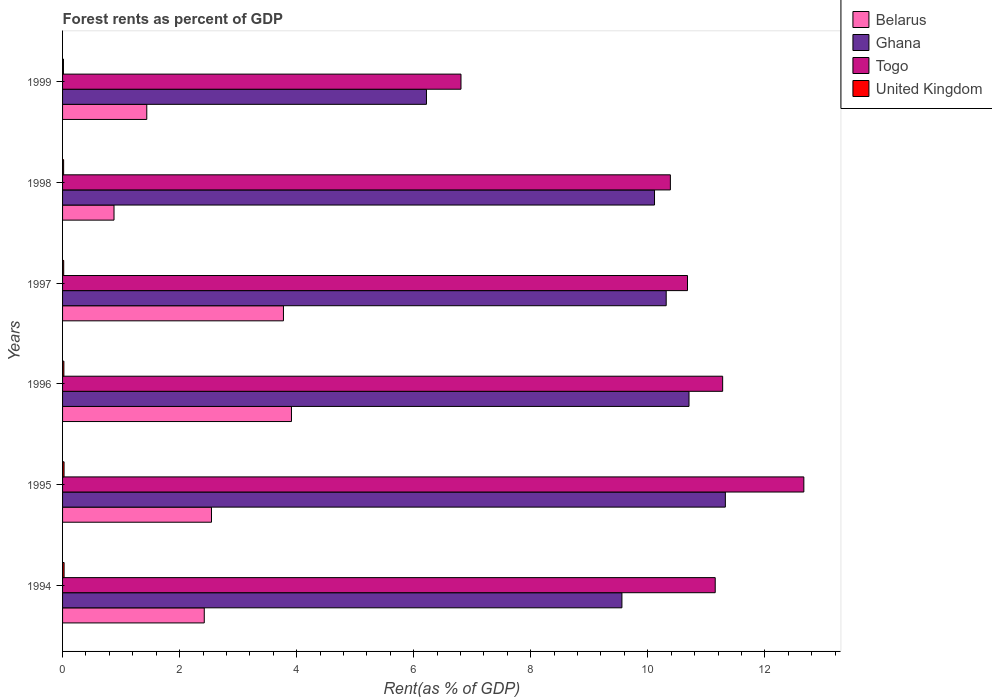How many groups of bars are there?
Offer a very short reply. 6. Are the number of bars per tick equal to the number of legend labels?
Provide a succinct answer. Yes. How many bars are there on the 6th tick from the top?
Your answer should be compact. 4. What is the forest rent in Togo in 1996?
Keep it short and to the point. 11.28. Across all years, what is the maximum forest rent in Belarus?
Provide a succinct answer. 3.91. Across all years, what is the minimum forest rent in Belarus?
Your response must be concise. 0.88. In which year was the forest rent in Togo minimum?
Your answer should be very brief. 1999. What is the total forest rent in United Kingdom in the graph?
Keep it short and to the point. 0.13. What is the difference between the forest rent in United Kingdom in 1994 and that in 1998?
Give a very brief answer. 0.01. What is the difference between the forest rent in Ghana in 1997 and the forest rent in United Kingdom in 1995?
Your answer should be compact. 10.29. What is the average forest rent in Togo per year?
Offer a terse response. 10.5. In the year 1999, what is the difference between the forest rent in Belarus and forest rent in Togo?
Ensure brevity in your answer.  -5.37. In how many years, is the forest rent in Belarus greater than 10 %?
Your response must be concise. 0. What is the ratio of the forest rent in Belarus in 1997 to that in 1999?
Your answer should be very brief. 2.62. Is the difference between the forest rent in Belarus in 1995 and 1999 greater than the difference between the forest rent in Togo in 1995 and 1999?
Your answer should be very brief. No. What is the difference between the highest and the second highest forest rent in Belarus?
Provide a succinct answer. 0.14. What is the difference between the highest and the lowest forest rent in Belarus?
Offer a terse response. 3.03. What does the 2nd bar from the top in 1999 represents?
Provide a succinct answer. Togo. What does the 3rd bar from the bottom in 1999 represents?
Offer a terse response. Togo. Is it the case that in every year, the sum of the forest rent in United Kingdom and forest rent in Togo is greater than the forest rent in Ghana?
Make the answer very short. Yes. Are all the bars in the graph horizontal?
Provide a succinct answer. Yes. How many years are there in the graph?
Your response must be concise. 6. Are the values on the major ticks of X-axis written in scientific E-notation?
Keep it short and to the point. No. Does the graph contain any zero values?
Your response must be concise. No. Where does the legend appear in the graph?
Make the answer very short. Top right. How many legend labels are there?
Your answer should be compact. 4. What is the title of the graph?
Your answer should be very brief. Forest rents as percent of GDP. Does "Uganda" appear as one of the legend labels in the graph?
Keep it short and to the point. No. What is the label or title of the X-axis?
Make the answer very short. Rent(as % of GDP). What is the Rent(as % of GDP) of Belarus in 1994?
Offer a terse response. 2.42. What is the Rent(as % of GDP) in Ghana in 1994?
Keep it short and to the point. 9.56. What is the Rent(as % of GDP) in Togo in 1994?
Your answer should be compact. 11.15. What is the Rent(as % of GDP) of United Kingdom in 1994?
Offer a very short reply. 0.03. What is the Rent(as % of GDP) of Belarus in 1995?
Provide a succinct answer. 2.54. What is the Rent(as % of GDP) in Ghana in 1995?
Make the answer very short. 11.33. What is the Rent(as % of GDP) of Togo in 1995?
Ensure brevity in your answer.  12.67. What is the Rent(as % of GDP) of United Kingdom in 1995?
Your answer should be compact. 0.03. What is the Rent(as % of GDP) of Belarus in 1996?
Offer a terse response. 3.91. What is the Rent(as % of GDP) of Ghana in 1996?
Your answer should be compact. 10.7. What is the Rent(as % of GDP) of Togo in 1996?
Ensure brevity in your answer.  11.28. What is the Rent(as % of GDP) of United Kingdom in 1996?
Your response must be concise. 0.02. What is the Rent(as % of GDP) of Belarus in 1997?
Keep it short and to the point. 3.77. What is the Rent(as % of GDP) of Ghana in 1997?
Your answer should be very brief. 10.31. What is the Rent(as % of GDP) of Togo in 1997?
Offer a very short reply. 10.68. What is the Rent(as % of GDP) of United Kingdom in 1997?
Offer a terse response. 0.02. What is the Rent(as % of GDP) in Belarus in 1998?
Offer a terse response. 0.88. What is the Rent(as % of GDP) in Ghana in 1998?
Provide a short and direct response. 10.12. What is the Rent(as % of GDP) in Togo in 1998?
Offer a very short reply. 10.39. What is the Rent(as % of GDP) in United Kingdom in 1998?
Your response must be concise. 0.02. What is the Rent(as % of GDP) in Belarus in 1999?
Your answer should be compact. 1.44. What is the Rent(as % of GDP) in Ghana in 1999?
Your answer should be very brief. 6.22. What is the Rent(as % of GDP) of Togo in 1999?
Offer a very short reply. 6.81. What is the Rent(as % of GDP) in United Kingdom in 1999?
Your response must be concise. 0.02. Across all years, what is the maximum Rent(as % of GDP) in Belarus?
Provide a succinct answer. 3.91. Across all years, what is the maximum Rent(as % of GDP) of Ghana?
Give a very brief answer. 11.33. Across all years, what is the maximum Rent(as % of GDP) of Togo?
Offer a very short reply. 12.67. Across all years, what is the maximum Rent(as % of GDP) in United Kingdom?
Your answer should be compact. 0.03. Across all years, what is the minimum Rent(as % of GDP) of Belarus?
Offer a terse response. 0.88. Across all years, what is the minimum Rent(as % of GDP) in Ghana?
Give a very brief answer. 6.22. Across all years, what is the minimum Rent(as % of GDP) of Togo?
Your response must be concise. 6.81. Across all years, what is the minimum Rent(as % of GDP) of United Kingdom?
Keep it short and to the point. 0.02. What is the total Rent(as % of GDP) in Belarus in the graph?
Your answer should be compact. 14.97. What is the total Rent(as % of GDP) in Ghana in the graph?
Provide a succinct answer. 58.24. What is the total Rent(as % of GDP) in Togo in the graph?
Ensure brevity in your answer.  62.97. What is the total Rent(as % of GDP) in United Kingdom in the graph?
Keep it short and to the point. 0.13. What is the difference between the Rent(as % of GDP) of Belarus in 1994 and that in 1995?
Offer a very short reply. -0.12. What is the difference between the Rent(as % of GDP) in Ghana in 1994 and that in 1995?
Make the answer very short. -1.77. What is the difference between the Rent(as % of GDP) in Togo in 1994 and that in 1995?
Offer a very short reply. -1.51. What is the difference between the Rent(as % of GDP) in United Kingdom in 1994 and that in 1995?
Your response must be concise. 0. What is the difference between the Rent(as % of GDP) of Belarus in 1994 and that in 1996?
Provide a succinct answer. -1.49. What is the difference between the Rent(as % of GDP) in Ghana in 1994 and that in 1996?
Keep it short and to the point. -1.15. What is the difference between the Rent(as % of GDP) in Togo in 1994 and that in 1996?
Give a very brief answer. -0.13. What is the difference between the Rent(as % of GDP) in United Kingdom in 1994 and that in 1996?
Your response must be concise. 0. What is the difference between the Rent(as % of GDP) of Belarus in 1994 and that in 1997?
Give a very brief answer. -1.35. What is the difference between the Rent(as % of GDP) in Ghana in 1994 and that in 1997?
Your response must be concise. -0.76. What is the difference between the Rent(as % of GDP) of Togo in 1994 and that in 1997?
Offer a terse response. 0.47. What is the difference between the Rent(as % of GDP) in United Kingdom in 1994 and that in 1997?
Your answer should be very brief. 0.01. What is the difference between the Rent(as % of GDP) of Belarus in 1994 and that in 1998?
Provide a succinct answer. 1.54. What is the difference between the Rent(as % of GDP) in Ghana in 1994 and that in 1998?
Make the answer very short. -0.56. What is the difference between the Rent(as % of GDP) of Togo in 1994 and that in 1998?
Keep it short and to the point. 0.77. What is the difference between the Rent(as % of GDP) of United Kingdom in 1994 and that in 1998?
Your answer should be very brief. 0.01. What is the difference between the Rent(as % of GDP) in Belarus in 1994 and that in 1999?
Make the answer very short. 0.98. What is the difference between the Rent(as % of GDP) of Ghana in 1994 and that in 1999?
Your answer should be compact. 3.34. What is the difference between the Rent(as % of GDP) of Togo in 1994 and that in 1999?
Make the answer very short. 4.34. What is the difference between the Rent(as % of GDP) in United Kingdom in 1994 and that in 1999?
Your answer should be compact. 0.01. What is the difference between the Rent(as % of GDP) of Belarus in 1995 and that in 1996?
Provide a short and direct response. -1.37. What is the difference between the Rent(as % of GDP) in Ghana in 1995 and that in 1996?
Your answer should be compact. 0.62. What is the difference between the Rent(as % of GDP) in Togo in 1995 and that in 1996?
Offer a terse response. 1.39. What is the difference between the Rent(as % of GDP) in United Kingdom in 1995 and that in 1996?
Ensure brevity in your answer.  0. What is the difference between the Rent(as % of GDP) of Belarus in 1995 and that in 1997?
Your answer should be compact. -1.23. What is the difference between the Rent(as % of GDP) in Ghana in 1995 and that in 1997?
Keep it short and to the point. 1.01. What is the difference between the Rent(as % of GDP) of Togo in 1995 and that in 1997?
Provide a succinct answer. 1.99. What is the difference between the Rent(as % of GDP) of United Kingdom in 1995 and that in 1997?
Your answer should be compact. 0.01. What is the difference between the Rent(as % of GDP) of Belarus in 1995 and that in 1998?
Your answer should be very brief. 1.67. What is the difference between the Rent(as % of GDP) in Ghana in 1995 and that in 1998?
Make the answer very short. 1.21. What is the difference between the Rent(as % of GDP) in Togo in 1995 and that in 1998?
Provide a short and direct response. 2.28. What is the difference between the Rent(as % of GDP) of United Kingdom in 1995 and that in 1998?
Your answer should be compact. 0.01. What is the difference between the Rent(as % of GDP) in Belarus in 1995 and that in 1999?
Your response must be concise. 1.11. What is the difference between the Rent(as % of GDP) of Ghana in 1995 and that in 1999?
Give a very brief answer. 5.11. What is the difference between the Rent(as % of GDP) in Togo in 1995 and that in 1999?
Your answer should be very brief. 5.86. What is the difference between the Rent(as % of GDP) of United Kingdom in 1995 and that in 1999?
Give a very brief answer. 0.01. What is the difference between the Rent(as % of GDP) of Belarus in 1996 and that in 1997?
Your response must be concise. 0.14. What is the difference between the Rent(as % of GDP) of Ghana in 1996 and that in 1997?
Provide a succinct answer. 0.39. What is the difference between the Rent(as % of GDP) in Togo in 1996 and that in 1997?
Your response must be concise. 0.6. What is the difference between the Rent(as % of GDP) in United Kingdom in 1996 and that in 1997?
Keep it short and to the point. 0. What is the difference between the Rent(as % of GDP) of Belarus in 1996 and that in 1998?
Your answer should be very brief. 3.03. What is the difference between the Rent(as % of GDP) in Ghana in 1996 and that in 1998?
Provide a succinct answer. 0.59. What is the difference between the Rent(as % of GDP) in Togo in 1996 and that in 1998?
Offer a terse response. 0.89. What is the difference between the Rent(as % of GDP) of United Kingdom in 1996 and that in 1998?
Provide a short and direct response. 0. What is the difference between the Rent(as % of GDP) of Belarus in 1996 and that in 1999?
Give a very brief answer. 2.47. What is the difference between the Rent(as % of GDP) in Ghana in 1996 and that in 1999?
Provide a succinct answer. 4.49. What is the difference between the Rent(as % of GDP) of Togo in 1996 and that in 1999?
Provide a short and direct response. 4.47. What is the difference between the Rent(as % of GDP) of United Kingdom in 1996 and that in 1999?
Keep it short and to the point. 0.01. What is the difference between the Rent(as % of GDP) of Belarus in 1997 and that in 1998?
Provide a succinct answer. 2.9. What is the difference between the Rent(as % of GDP) of Ghana in 1997 and that in 1998?
Your answer should be compact. 0.2. What is the difference between the Rent(as % of GDP) of Togo in 1997 and that in 1998?
Keep it short and to the point. 0.29. What is the difference between the Rent(as % of GDP) of United Kingdom in 1997 and that in 1998?
Offer a very short reply. 0. What is the difference between the Rent(as % of GDP) of Belarus in 1997 and that in 1999?
Ensure brevity in your answer.  2.34. What is the difference between the Rent(as % of GDP) in Ghana in 1997 and that in 1999?
Keep it short and to the point. 4.1. What is the difference between the Rent(as % of GDP) of Togo in 1997 and that in 1999?
Provide a succinct answer. 3.87. What is the difference between the Rent(as % of GDP) of United Kingdom in 1997 and that in 1999?
Provide a short and direct response. 0. What is the difference between the Rent(as % of GDP) of Belarus in 1998 and that in 1999?
Your response must be concise. -0.56. What is the difference between the Rent(as % of GDP) of Ghana in 1998 and that in 1999?
Your answer should be compact. 3.9. What is the difference between the Rent(as % of GDP) in Togo in 1998 and that in 1999?
Offer a very short reply. 3.58. What is the difference between the Rent(as % of GDP) in United Kingdom in 1998 and that in 1999?
Give a very brief answer. 0. What is the difference between the Rent(as % of GDP) in Belarus in 1994 and the Rent(as % of GDP) in Ghana in 1995?
Your response must be concise. -8.9. What is the difference between the Rent(as % of GDP) in Belarus in 1994 and the Rent(as % of GDP) in Togo in 1995?
Ensure brevity in your answer.  -10.25. What is the difference between the Rent(as % of GDP) of Belarus in 1994 and the Rent(as % of GDP) of United Kingdom in 1995?
Your answer should be compact. 2.4. What is the difference between the Rent(as % of GDP) in Ghana in 1994 and the Rent(as % of GDP) in Togo in 1995?
Give a very brief answer. -3.11. What is the difference between the Rent(as % of GDP) in Ghana in 1994 and the Rent(as % of GDP) in United Kingdom in 1995?
Provide a short and direct response. 9.53. What is the difference between the Rent(as % of GDP) of Togo in 1994 and the Rent(as % of GDP) of United Kingdom in 1995?
Your response must be concise. 11.13. What is the difference between the Rent(as % of GDP) in Belarus in 1994 and the Rent(as % of GDP) in Ghana in 1996?
Provide a succinct answer. -8.28. What is the difference between the Rent(as % of GDP) of Belarus in 1994 and the Rent(as % of GDP) of Togo in 1996?
Provide a short and direct response. -8.86. What is the difference between the Rent(as % of GDP) of Belarus in 1994 and the Rent(as % of GDP) of United Kingdom in 1996?
Make the answer very short. 2.4. What is the difference between the Rent(as % of GDP) of Ghana in 1994 and the Rent(as % of GDP) of Togo in 1996?
Your answer should be compact. -1.72. What is the difference between the Rent(as % of GDP) of Ghana in 1994 and the Rent(as % of GDP) of United Kingdom in 1996?
Make the answer very short. 9.54. What is the difference between the Rent(as % of GDP) of Togo in 1994 and the Rent(as % of GDP) of United Kingdom in 1996?
Your answer should be compact. 11.13. What is the difference between the Rent(as % of GDP) in Belarus in 1994 and the Rent(as % of GDP) in Ghana in 1997?
Ensure brevity in your answer.  -7.89. What is the difference between the Rent(as % of GDP) of Belarus in 1994 and the Rent(as % of GDP) of Togo in 1997?
Offer a terse response. -8.26. What is the difference between the Rent(as % of GDP) of Belarus in 1994 and the Rent(as % of GDP) of United Kingdom in 1997?
Your answer should be compact. 2.4. What is the difference between the Rent(as % of GDP) of Ghana in 1994 and the Rent(as % of GDP) of Togo in 1997?
Provide a short and direct response. -1.12. What is the difference between the Rent(as % of GDP) of Ghana in 1994 and the Rent(as % of GDP) of United Kingdom in 1997?
Give a very brief answer. 9.54. What is the difference between the Rent(as % of GDP) in Togo in 1994 and the Rent(as % of GDP) in United Kingdom in 1997?
Offer a terse response. 11.13. What is the difference between the Rent(as % of GDP) of Belarus in 1994 and the Rent(as % of GDP) of Ghana in 1998?
Provide a short and direct response. -7.69. What is the difference between the Rent(as % of GDP) of Belarus in 1994 and the Rent(as % of GDP) of Togo in 1998?
Keep it short and to the point. -7.96. What is the difference between the Rent(as % of GDP) in Belarus in 1994 and the Rent(as % of GDP) in United Kingdom in 1998?
Offer a very short reply. 2.4. What is the difference between the Rent(as % of GDP) in Ghana in 1994 and the Rent(as % of GDP) in Togo in 1998?
Your answer should be compact. -0.83. What is the difference between the Rent(as % of GDP) of Ghana in 1994 and the Rent(as % of GDP) of United Kingdom in 1998?
Give a very brief answer. 9.54. What is the difference between the Rent(as % of GDP) of Togo in 1994 and the Rent(as % of GDP) of United Kingdom in 1998?
Offer a very short reply. 11.13. What is the difference between the Rent(as % of GDP) of Belarus in 1994 and the Rent(as % of GDP) of Ghana in 1999?
Provide a succinct answer. -3.8. What is the difference between the Rent(as % of GDP) of Belarus in 1994 and the Rent(as % of GDP) of Togo in 1999?
Your answer should be very brief. -4.39. What is the difference between the Rent(as % of GDP) of Belarus in 1994 and the Rent(as % of GDP) of United Kingdom in 1999?
Give a very brief answer. 2.41. What is the difference between the Rent(as % of GDP) in Ghana in 1994 and the Rent(as % of GDP) in Togo in 1999?
Your answer should be compact. 2.75. What is the difference between the Rent(as % of GDP) in Ghana in 1994 and the Rent(as % of GDP) in United Kingdom in 1999?
Your answer should be very brief. 9.54. What is the difference between the Rent(as % of GDP) of Togo in 1994 and the Rent(as % of GDP) of United Kingdom in 1999?
Your answer should be very brief. 11.14. What is the difference between the Rent(as % of GDP) of Belarus in 1995 and the Rent(as % of GDP) of Ghana in 1996?
Make the answer very short. -8.16. What is the difference between the Rent(as % of GDP) of Belarus in 1995 and the Rent(as % of GDP) of Togo in 1996?
Provide a short and direct response. -8.73. What is the difference between the Rent(as % of GDP) in Belarus in 1995 and the Rent(as % of GDP) in United Kingdom in 1996?
Offer a very short reply. 2.52. What is the difference between the Rent(as % of GDP) in Ghana in 1995 and the Rent(as % of GDP) in Togo in 1996?
Your answer should be compact. 0.05. What is the difference between the Rent(as % of GDP) of Ghana in 1995 and the Rent(as % of GDP) of United Kingdom in 1996?
Your answer should be compact. 11.3. What is the difference between the Rent(as % of GDP) in Togo in 1995 and the Rent(as % of GDP) in United Kingdom in 1996?
Provide a succinct answer. 12.64. What is the difference between the Rent(as % of GDP) of Belarus in 1995 and the Rent(as % of GDP) of Ghana in 1997?
Your response must be concise. -7.77. What is the difference between the Rent(as % of GDP) of Belarus in 1995 and the Rent(as % of GDP) of Togo in 1997?
Your answer should be very brief. -8.13. What is the difference between the Rent(as % of GDP) in Belarus in 1995 and the Rent(as % of GDP) in United Kingdom in 1997?
Make the answer very short. 2.53. What is the difference between the Rent(as % of GDP) of Ghana in 1995 and the Rent(as % of GDP) of Togo in 1997?
Offer a terse response. 0.65. What is the difference between the Rent(as % of GDP) in Ghana in 1995 and the Rent(as % of GDP) in United Kingdom in 1997?
Your response must be concise. 11.31. What is the difference between the Rent(as % of GDP) of Togo in 1995 and the Rent(as % of GDP) of United Kingdom in 1997?
Give a very brief answer. 12.65. What is the difference between the Rent(as % of GDP) in Belarus in 1995 and the Rent(as % of GDP) in Ghana in 1998?
Your answer should be very brief. -7.57. What is the difference between the Rent(as % of GDP) in Belarus in 1995 and the Rent(as % of GDP) in Togo in 1998?
Keep it short and to the point. -7.84. What is the difference between the Rent(as % of GDP) of Belarus in 1995 and the Rent(as % of GDP) of United Kingdom in 1998?
Ensure brevity in your answer.  2.53. What is the difference between the Rent(as % of GDP) in Ghana in 1995 and the Rent(as % of GDP) in Togo in 1998?
Give a very brief answer. 0.94. What is the difference between the Rent(as % of GDP) in Ghana in 1995 and the Rent(as % of GDP) in United Kingdom in 1998?
Ensure brevity in your answer.  11.31. What is the difference between the Rent(as % of GDP) of Togo in 1995 and the Rent(as % of GDP) of United Kingdom in 1998?
Make the answer very short. 12.65. What is the difference between the Rent(as % of GDP) in Belarus in 1995 and the Rent(as % of GDP) in Ghana in 1999?
Keep it short and to the point. -3.67. What is the difference between the Rent(as % of GDP) of Belarus in 1995 and the Rent(as % of GDP) of Togo in 1999?
Give a very brief answer. -4.26. What is the difference between the Rent(as % of GDP) in Belarus in 1995 and the Rent(as % of GDP) in United Kingdom in 1999?
Your answer should be compact. 2.53. What is the difference between the Rent(as % of GDP) in Ghana in 1995 and the Rent(as % of GDP) in Togo in 1999?
Your answer should be compact. 4.52. What is the difference between the Rent(as % of GDP) in Ghana in 1995 and the Rent(as % of GDP) in United Kingdom in 1999?
Offer a very short reply. 11.31. What is the difference between the Rent(as % of GDP) of Togo in 1995 and the Rent(as % of GDP) of United Kingdom in 1999?
Your answer should be compact. 12.65. What is the difference between the Rent(as % of GDP) of Belarus in 1996 and the Rent(as % of GDP) of Ghana in 1997?
Offer a terse response. -6.4. What is the difference between the Rent(as % of GDP) of Belarus in 1996 and the Rent(as % of GDP) of Togo in 1997?
Your answer should be compact. -6.77. What is the difference between the Rent(as % of GDP) of Belarus in 1996 and the Rent(as % of GDP) of United Kingdom in 1997?
Your answer should be compact. 3.89. What is the difference between the Rent(as % of GDP) of Ghana in 1996 and the Rent(as % of GDP) of Togo in 1997?
Keep it short and to the point. 0.03. What is the difference between the Rent(as % of GDP) of Ghana in 1996 and the Rent(as % of GDP) of United Kingdom in 1997?
Provide a short and direct response. 10.69. What is the difference between the Rent(as % of GDP) of Togo in 1996 and the Rent(as % of GDP) of United Kingdom in 1997?
Offer a very short reply. 11.26. What is the difference between the Rent(as % of GDP) of Belarus in 1996 and the Rent(as % of GDP) of Ghana in 1998?
Provide a succinct answer. -6.2. What is the difference between the Rent(as % of GDP) of Belarus in 1996 and the Rent(as % of GDP) of Togo in 1998?
Your answer should be compact. -6.47. What is the difference between the Rent(as % of GDP) in Belarus in 1996 and the Rent(as % of GDP) in United Kingdom in 1998?
Offer a very short reply. 3.89. What is the difference between the Rent(as % of GDP) in Ghana in 1996 and the Rent(as % of GDP) in Togo in 1998?
Offer a very short reply. 0.32. What is the difference between the Rent(as % of GDP) in Ghana in 1996 and the Rent(as % of GDP) in United Kingdom in 1998?
Offer a very short reply. 10.69. What is the difference between the Rent(as % of GDP) of Togo in 1996 and the Rent(as % of GDP) of United Kingdom in 1998?
Make the answer very short. 11.26. What is the difference between the Rent(as % of GDP) of Belarus in 1996 and the Rent(as % of GDP) of Ghana in 1999?
Give a very brief answer. -2.31. What is the difference between the Rent(as % of GDP) of Belarus in 1996 and the Rent(as % of GDP) of Togo in 1999?
Offer a terse response. -2.9. What is the difference between the Rent(as % of GDP) of Belarus in 1996 and the Rent(as % of GDP) of United Kingdom in 1999?
Your answer should be very brief. 3.9. What is the difference between the Rent(as % of GDP) of Ghana in 1996 and the Rent(as % of GDP) of Togo in 1999?
Provide a short and direct response. 3.9. What is the difference between the Rent(as % of GDP) of Ghana in 1996 and the Rent(as % of GDP) of United Kingdom in 1999?
Provide a succinct answer. 10.69. What is the difference between the Rent(as % of GDP) in Togo in 1996 and the Rent(as % of GDP) in United Kingdom in 1999?
Your response must be concise. 11.26. What is the difference between the Rent(as % of GDP) in Belarus in 1997 and the Rent(as % of GDP) in Ghana in 1998?
Make the answer very short. -6.34. What is the difference between the Rent(as % of GDP) in Belarus in 1997 and the Rent(as % of GDP) in Togo in 1998?
Offer a terse response. -6.61. What is the difference between the Rent(as % of GDP) of Belarus in 1997 and the Rent(as % of GDP) of United Kingdom in 1998?
Keep it short and to the point. 3.76. What is the difference between the Rent(as % of GDP) of Ghana in 1997 and the Rent(as % of GDP) of Togo in 1998?
Ensure brevity in your answer.  -0.07. What is the difference between the Rent(as % of GDP) in Ghana in 1997 and the Rent(as % of GDP) in United Kingdom in 1998?
Give a very brief answer. 10.3. What is the difference between the Rent(as % of GDP) in Togo in 1997 and the Rent(as % of GDP) in United Kingdom in 1998?
Provide a short and direct response. 10.66. What is the difference between the Rent(as % of GDP) in Belarus in 1997 and the Rent(as % of GDP) in Ghana in 1999?
Offer a terse response. -2.44. What is the difference between the Rent(as % of GDP) of Belarus in 1997 and the Rent(as % of GDP) of Togo in 1999?
Your answer should be compact. -3.03. What is the difference between the Rent(as % of GDP) of Belarus in 1997 and the Rent(as % of GDP) of United Kingdom in 1999?
Provide a succinct answer. 3.76. What is the difference between the Rent(as % of GDP) of Ghana in 1997 and the Rent(as % of GDP) of Togo in 1999?
Give a very brief answer. 3.51. What is the difference between the Rent(as % of GDP) in Ghana in 1997 and the Rent(as % of GDP) in United Kingdom in 1999?
Provide a succinct answer. 10.3. What is the difference between the Rent(as % of GDP) in Togo in 1997 and the Rent(as % of GDP) in United Kingdom in 1999?
Keep it short and to the point. 10.66. What is the difference between the Rent(as % of GDP) of Belarus in 1998 and the Rent(as % of GDP) of Ghana in 1999?
Offer a terse response. -5.34. What is the difference between the Rent(as % of GDP) of Belarus in 1998 and the Rent(as % of GDP) of Togo in 1999?
Provide a short and direct response. -5.93. What is the difference between the Rent(as % of GDP) in Belarus in 1998 and the Rent(as % of GDP) in United Kingdom in 1999?
Make the answer very short. 0.86. What is the difference between the Rent(as % of GDP) of Ghana in 1998 and the Rent(as % of GDP) of Togo in 1999?
Ensure brevity in your answer.  3.31. What is the difference between the Rent(as % of GDP) of Ghana in 1998 and the Rent(as % of GDP) of United Kingdom in 1999?
Your answer should be very brief. 10.1. What is the difference between the Rent(as % of GDP) of Togo in 1998 and the Rent(as % of GDP) of United Kingdom in 1999?
Your response must be concise. 10.37. What is the average Rent(as % of GDP) in Belarus per year?
Your answer should be very brief. 2.5. What is the average Rent(as % of GDP) in Ghana per year?
Offer a terse response. 9.71. What is the average Rent(as % of GDP) of Togo per year?
Keep it short and to the point. 10.5. What is the average Rent(as % of GDP) in United Kingdom per year?
Provide a succinct answer. 0.02. In the year 1994, what is the difference between the Rent(as % of GDP) of Belarus and Rent(as % of GDP) of Ghana?
Offer a very short reply. -7.14. In the year 1994, what is the difference between the Rent(as % of GDP) of Belarus and Rent(as % of GDP) of Togo?
Your response must be concise. -8.73. In the year 1994, what is the difference between the Rent(as % of GDP) of Belarus and Rent(as % of GDP) of United Kingdom?
Ensure brevity in your answer.  2.4. In the year 1994, what is the difference between the Rent(as % of GDP) of Ghana and Rent(as % of GDP) of Togo?
Provide a succinct answer. -1.59. In the year 1994, what is the difference between the Rent(as % of GDP) of Ghana and Rent(as % of GDP) of United Kingdom?
Provide a short and direct response. 9.53. In the year 1994, what is the difference between the Rent(as % of GDP) in Togo and Rent(as % of GDP) in United Kingdom?
Provide a succinct answer. 11.13. In the year 1995, what is the difference between the Rent(as % of GDP) of Belarus and Rent(as % of GDP) of Ghana?
Provide a short and direct response. -8.78. In the year 1995, what is the difference between the Rent(as % of GDP) in Belarus and Rent(as % of GDP) in Togo?
Your response must be concise. -10.12. In the year 1995, what is the difference between the Rent(as % of GDP) of Belarus and Rent(as % of GDP) of United Kingdom?
Give a very brief answer. 2.52. In the year 1995, what is the difference between the Rent(as % of GDP) in Ghana and Rent(as % of GDP) in Togo?
Make the answer very short. -1.34. In the year 1995, what is the difference between the Rent(as % of GDP) in Ghana and Rent(as % of GDP) in United Kingdom?
Keep it short and to the point. 11.3. In the year 1995, what is the difference between the Rent(as % of GDP) in Togo and Rent(as % of GDP) in United Kingdom?
Make the answer very short. 12.64. In the year 1996, what is the difference between the Rent(as % of GDP) of Belarus and Rent(as % of GDP) of Ghana?
Your answer should be compact. -6.79. In the year 1996, what is the difference between the Rent(as % of GDP) of Belarus and Rent(as % of GDP) of Togo?
Your answer should be very brief. -7.37. In the year 1996, what is the difference between the Rent(as % of GDP) in Belarus and Rent(as % of GDP) in United Kingdom?
Your answer should be very brief. 3.89. In the year 1996, what is the difference between the Rent(as % of GDP) in Ghana and Rent(as % of GDP) in Togo?
Your answer should be compact. -0.57. In the year 1996, what is the difference between the Rent(as % of GDP) of Ghana and Rent(as % of GDP) of United Kingdom?
Your answer should be compact. 10.68. In the year 1996, what is the difference between the Rent(as % of GDP) in Togo and Rent(as % of GDP) in United Kingdom?
Offer a very short reply. 11.26. In the year 1997, what is the difference between the Rent(as % of GDP) in Belarus and Rent(as % of GDP) in Ghana?
Provide a succinct answer. -6.54. In the year 1997, what is the difference between the Rent(as % of GDP) in Belarus and Rent(as % of GDP) in Togo?
Provide a short and direct response. -6.9. In the year 1997, what is the difference between the Rent(as % of GDP) in Belarus and Rent(as % of GDP) in United Kingdom?
Give a very brief answer. 3.75. In the year 1997, what is the difference between the Rent(as % of GDP) in Ghana and Rent(as % of GDP) in Togo?
Provide a succinct answer. -0.36. In the year 1997, what is the difference between the Rent(as % of GDP) of Ghana and Rent(as % of GDP) of United Kingdom?
Keep it short and to the point. 10.3. In the year 1997, what is the difference between the Rent(as % of GDP) of Togo and Rent(as % of GDP) of United Kingdom?
Your answer should be very brief. 10.66. In the year 1998, what is the difference between the Rent(as % of GDP) of Belarus and Rent(as % of GDP) of Ghana?
Ensure brevity in your answer.  -9.24. In the year 1998, what is the difference between the Rent(as % of GDP) of Belarus and Rent(as % of GDP) of Togo?
Provide a short and direct response. -9.51. In the year 1998, what is the difference between the Rent(as % of GDP) of Belarus and Rent(as % of GDP) of United Kingdom?
Your response must be concise. 0.86. In the year 1998, what is the difference between the Rent(as % of GDP) in Ghana and Rent(as % of GDP) in Togo?
Ensure brevity in your answer.  -0.27. In the year 1998, what is the difference between the Rent(as % of GDP) in Ghana and Rent(as % of GDP) in United Kingdom?
Your response must be concise. 10.1. In the year 1998, what is the difference between the Rent(as % of GDP) of Togo and Rent(as % of GDP) of United Kingdom?
Give a very brief answer. 10.37. In the year 1999, what is the difference between the Rent(as % of GDP) in Belarus and Rent(as % of GDP) in Ghana?
Keep it short and to the point. -4.78. In the year 1999, what is the difference between the Rent(as % of GDP) in Belarus and Rent(as % of GDP) in Togo?
Ensure brevity in your answer.  -5.37. In the year 1999, what is the difference between the Rent(as % of GDP) of Belarus and Rent(as % of GDP) of United Kingdom?
Provide a short and direct response. 1.42. In the year 1999, what is the difference between the Rent(as % of GDP) of Ghana and Rent(as % of GDP) of Togo?
Your answer should be very brief. -0.59. In the year 1999, what is the difference between the Rent(as % of GDP) of Ghana and Rent(as % of GDP) of United Kingdom?
Your answer should be compact. 6.2. In the year 1999, what is the difference between the Rent(as % of GDP) of Togo and Rent(as % of GDP) of United Kingdom?
Provide a succinct answer. 6.79. What is the ratio of the Rent(as % of GDP) in Belarus in 1994 to that in 1995?
Offer a very short reply. 0.95. What is the ratio of the Rent(as % of GDP) in Ghana in 1994 to that in 1995?
Offer a terse response. 0.84. What is the ratio of the Rent(as % of GDP) of Togo in 1994 to that in 1995?
Keep it short and to the point. 0.88. What is the ratio of the Rent(as % of GDP) in United Kingdom in 1994 to that in 1995?
Your answer should be very brief. 1.02. What is the ratio of the Rent(as % of GDP) in Belarus in 1994 to that in 1996?
Give a very brief answer. 0.62. What is the ratio of the Rent(as % of GDP) of Ghana in 1994 to that in 1996?
Provide a succinct answer. 0.89. What is the ratio of the Rent(as % of GDP) in Togo in 1994 to that in 1996?
Provide a succinct answer. 0.99. What is the ratio of the Rent(as % of GDP) of United Kingdom in 1994 to that in 1996?
Give a very brief answer. 1.15. What is the ratio of the Rent(as % of GDP) in Belarus in 1994 to that in 1997?
Your answer should be compact. 0.64. What is the ratio of the Rent(as % of GDP) of Ghana in 1994 to that in 1997?
Keep it short and to the point. 0.93. What is the ratio of the Rent(as % of GDP) in Togo in 1994 to that in 1997?
Offer a very short reply. 1.04. What is the ratio of the Rent(as % of GDP) of United Kingdom in 1994 to that in 1997?
Your answer should be compact. 1.34. What is the ratio of the Rent(as % of GDP) in Belarus in 1994 to that in 1998?
Offer a very short reply. 2.75. What is the ratio of the Rent(as % of GDP) of Ghana in 1994 to that in 1998?
Provide a succinct answer. 0.94. What is the ratio of the Rent(as % of GDP) in Togo in 1994 to that in 1998?
Provide a succinct answer. 1.07. What is the ratio of the Rent(as % of GDP) in United Kingdom in 1994 to that in 1998?
Offer a very short reply. 1.44. What is the ratio of the Rent(as % of GDP) in Belarus in 1994 to that in 1999?
Provide a succinct answer. 1.68. What is the ratio of the Rent(as % of GDP) of Ghana in 1994 to that in 1999?
Provide a succinct answer. 1.54. What is the ratio of the Rent(as % of GDP) in Togo in 1994 to that in 1999?
Offer a terse response. 1.64. What is the ratio of the Rent(as % of GDP) of United Kingdom in 1994 to that in 1999?
Your answer should be very brief. 1.71. What is the ratio of the Rent(as % of GDP) of Belarus in 1995 to that in 1996?
Make the answer very short. 0.65. What is the ratio of the Rent(as % of GDP) of Ghana in 1995 to that in 1996?
Your answer should be compact. 1.06. What is the ratio of the Rent(as % of GDP) in Togo in 1995 to that in 1996?
Give a very brief answer. 1.12. What is the ratio of the Rent(as % of GDP) in United Kingdom in 1995 to that in 1996?
Make the answer very short. 1.12. What is the ratio of the Rent(as % of GDP) in Belarus in 1995 to that in 1997?
Offer a terse response. 0.67. What is the ratio of the Rent(as % of GDP) of Ghana in 1995 to that in 1997?
Your answer should be compact. 1.1. What is the ratio of the Rent(as % of GDP) in Togo in 1995 to that in 1997?
Offer a very short reply. 1.19. What is the ratio of the Rent(as % of GDP) of United Kingdom in 1995 to that in 1997?
Keep it short and to the point. 1.31. What is the ratio of the Rent(as % of GDP) in Belarus in 1995 to that in 1998?
Provide a succinct answer. 2.89. What is the ratio of the Rent(as % of GDP) in Ghana in 1995 to that in 1998?
Offer a very short reply. 1.12. What is the ratio of the Rent(as % of GDP) of Togo in 1995 to that in 1998?
Give a very brief answer. 1.22. What is the ratio of the Rent(as % of GDP) of United Kingdom in 1995 to that in 1998?
Your answer should be compact. 1.41. What is the ratio of the Rent(as % of GDP) in Belarus in 1995 to that in 1999?
Provide a short and direct response. 1.77. What is the ratio of the Rent(as % of GDP) of Ghana in 1995 to that in 1999?
Your answer should be very brief. 1.82. What is the ratio of the Rent(as % of GDP) in Togo in 1995 to that in 1999?
Offer a very short reply. 1.86. What is the ratio of the Rent(as % of GDP) in United Kingdom in 1995 to that in 1999?
Your answer should be very brief. 1.67. What is the ratio of the Rent(as % of GDP) of Belarus in 1996 to that in 1997?
Your response must be concise. 1.04. What is the ratio of the Rent(as % of GDP) in Ghana in 1996 to that in 1997?
Keep it short and to the point. 1.04. What is the ratio of the Rent(as % of GDP) of Togo in 1996 to that in 1997?
Provide a short and direct response. 1.06. What is the ratio of the Rent(as % of GDP) in United Kingdom in 1996 to that in 1997?
Your answer should be very brief. 1.17. What is the ratio of the Rent(as % of GDP) in Belarus in 1996 to that in 1998?
Your response must be concise. 4.45. What is the ratio of the Rent(as % of GDP) of Ghana in 1996 to that in 1998?
Provide a short and direct response. 1.06. What is the ratio of the Rent(as % of GDP) in Togo in 1996 to that in 1998?
Offer a very short reply. 1.09. What is the ratio of the Rent(as % of GDP) of United Kingdom in 1996 to that in 1998?
Your answer should be very brief. 1.25. What is the ratio of the Rent(as % of GDP) of Belarus in 1996 to that in 1999?
Provide a short and direct response. 2.72. What is the ratio of the Rent(as % of GDP) in Ghana in 1996 to that in 1999?
Your response must be concise. 1.72. What is the ratio of the Rent(as % of GDP) of Togo in 1996 to that in 1999?
Provide a short and direct response. 1.66. What is the ratio of the Rent(as % of GDP) in United Kingdom in 1996 to that in 1999?
Make the answer very short. 1.49. What is the ratio of the Rent(as % of GDP) of Belarus in 1997 to that in 1998?
Your answer should be very brief. 4.29. What is the ratio of the Rent(as % of GDP) of Ghana in 1997 to that in 1998?
Give a very brief answer. 1.02. What is the ratio of the Rent(as % of GDP) in Togo in 1997 to that in 1998?
Your response must be concise. 1.03. What is the ratio of the Rent(as % of GDP) of United Kingdom in 1997 to that in 1998?
Offer a terse response. 1.08. What is the ratio of the Rent(as % of GDP) in Belarus in 1997 to that in 1999?
Provide a short and direct response. 2.62. What is the ratio of the Rent(as % of GDP) in Ghana in 1997 to that in 1999?
Provide a succinct answer. 1.66. What is the ratio of the Rent(as % of GDP) of Togo in 1997 to that in 1999?
Provide a succinct answer. 1.57. What is the ratio of the Rent(as % of GDP) in United Kingdom in 1997 to that in 1999?
Offer a terse response. 1.27. What is the ratio of the Rent(as % of GDP) in Belarus in 1998 to that in 1999?
Ensure brevity in your answer.  0.61. What is the ratio of the Rent(as % of GDP) in Ghana in 1998 to that in 1999?
Your answer should be very brief. 1.63. What is the ratio of the Rent(as % of GDP) of Togo in 1998 to that in 1999?
Your answer should be very brief. 1.53. What is the ratio of the Rent(as % of GDP) in United Kingdom in 1998 to that in 1999?
Provide a short and direct response. 1.19. What is the difference between the highest and the second highest Rent(as % of GDP) in Belarus?
Your response must be concise. 0.14. What is the difference between the highest and the second highest Rent(as % of GDP) of Ghana?
Ensure brevity in your answer.  0.62. What is the difference between the highest and the second highest Rent(as % of GDP) of Togo?
Provide a short and direct response. 1.39. What is the difference between the highest and the second highest Rent(as % of GDP) of United Kingdom?
Your response must be concise. 0. What is the difference between the highest and the lowest Rent(as % of GDP) in Belarus?
Provide a succinct answer. 3.03. What is the difference between the highest and the lowest Rent(as % of GDP) of Ghana?
Give a very brief answer. 5.11. What is the difference between the highest and the lowest Rent(as % of GDP) in Togo?
Your answer should be very brief. 5.86. What is the difference between the highest and the lowest Rent(as % of GDP) in United Kingdom?
Give a very brief answer. 0.01. 